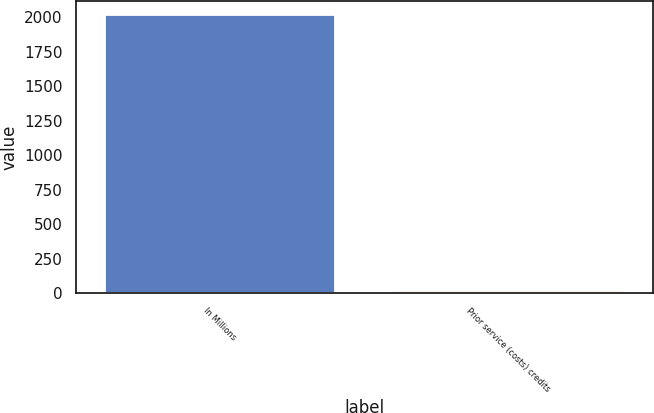<chart> <loc_0><loc_0><loc_500><loc_500><bar_chart><fcel>In Millions<fcel>Prior service (costs) credits<nl><fcel>2015<fcel>13.8<nl></chart> 